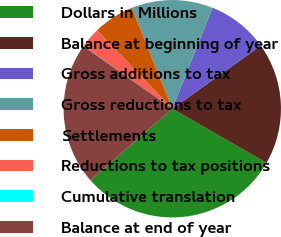Convert chart. <chart><loc_0><loc_0><loc_500><loc_500><pie_chart><fcel>Dollars in Millions<fcel>Balance at beginning of year<fcel>Gross additions to tax<fcel>Gross reductions to tax<fcel>Settlements<fcel>Reductions to tax positions<fcel>Cumulative translation<fcel>Balance at end of year<nl><fcel>30.26%<fcel>18.17%<fcel>9.1%<fcel>12.12%<fcel>6.08%<fcel>3.05%<fcel>0.03%<fcel>21.19%<nl></chart> 